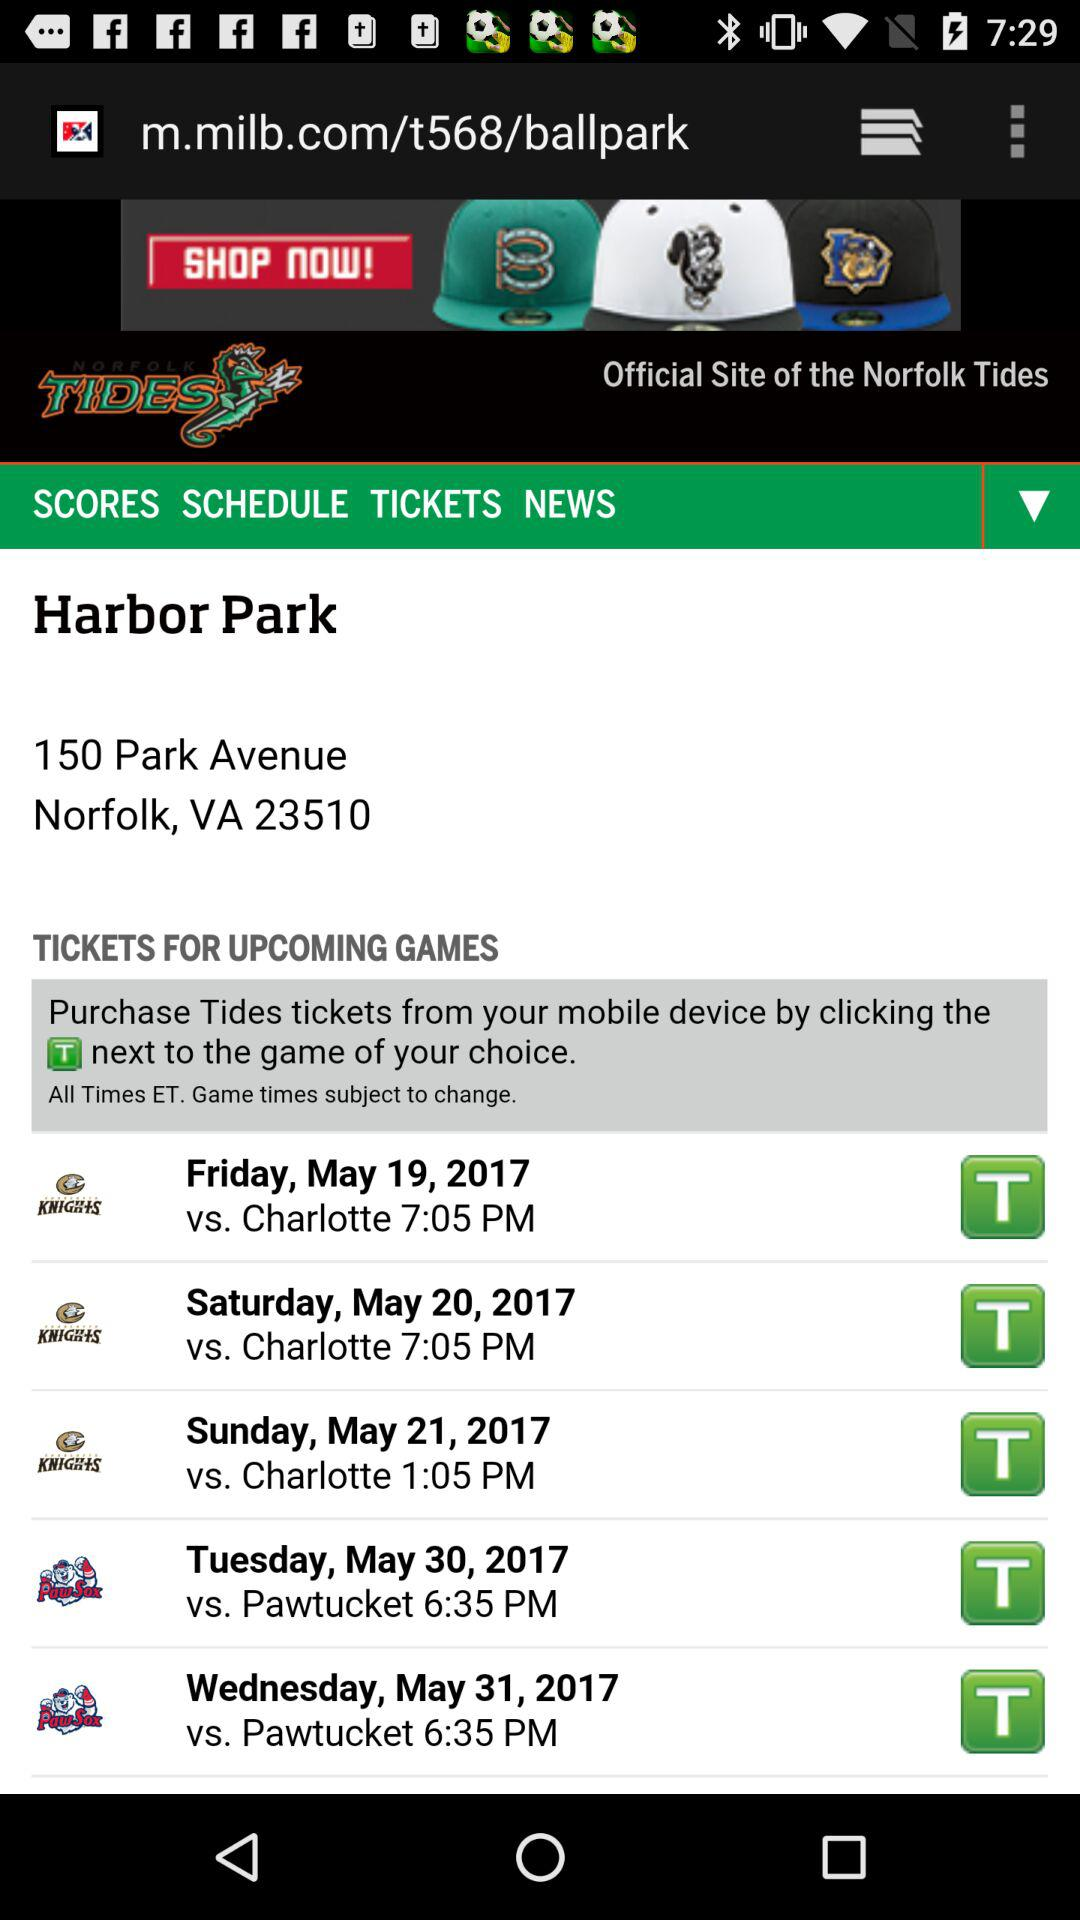When does the match start on May 30, 2017? The match starts at 6:35 PM. 